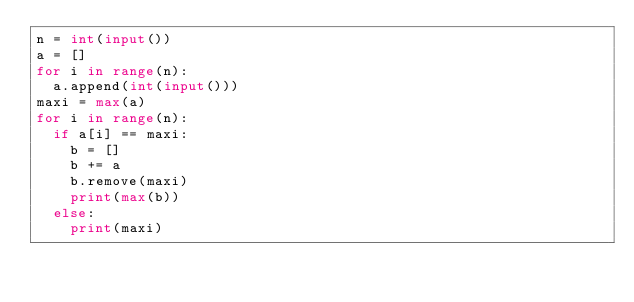<code> <loc_0><loc_0><loc_500><loc_500><_Python_>n = int(input())
a = []
for i in range(n):
  a.append(int(input()))
maxi = max(a)
for i in range(n):
  if a[i] == maxi:
    b = []
    b += a
    b.remove(maxi)
    print(max(b))
  else:
    print(maxi)</code> 